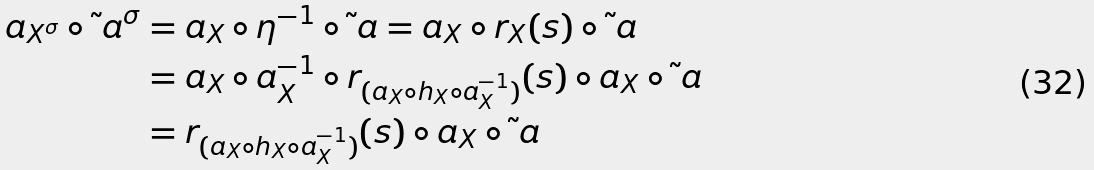Convert formula to latex. <formula><loc_0><loc_0><loc_500><loc_500>a _ { X ^ { \sigma } } \circ \tilde { \ } a ^ { \sigma } & = a _ { X } \circ \eta ^ { - 1 } \circ \tilde { \ } a = a _ { X } \circ r _ { X } ( s ) \circ \tilde { \ } a \\ & = a _ { X } \circ a _ { X } ^ { - 1 } \circ r _ { ( a _ { X } \circ h _ { X } \circ a _ { X } ^ { - 1 } ) } ( s ) \circ a _ { X } \circ \tilde { \ } a \\ & = r _ { ( a _ { X } \circ h _ { X } \circ a _ { X } ^ { - 1 } ) } ( s ) \circ a _ { X } \circ \tilde { \ } a</formula> 